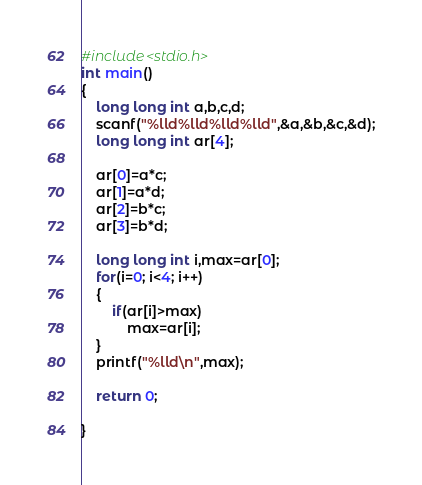Convert code to text. <code><loc_0><loc_0><loc_500><loc_500><_C_>#include<stdio.h>
int main()
{
    long long int a,b,c,d;
    scanf("%lld%lld%lld%lld",&a,&b,&c,&d);
    long long int ar[4];

    ar[0]=a*c;
    ar[1]=a*d;
    ar[2]=b*c;
    ar[3]=b*d;

    long long int i,max=ar[0];
    for(i=0; i<4; i++)
    {
        if(ar[i]>max)
            max=ar[i];
    }
    printf("%lld\n",max);

    return 0;

}
</code> 